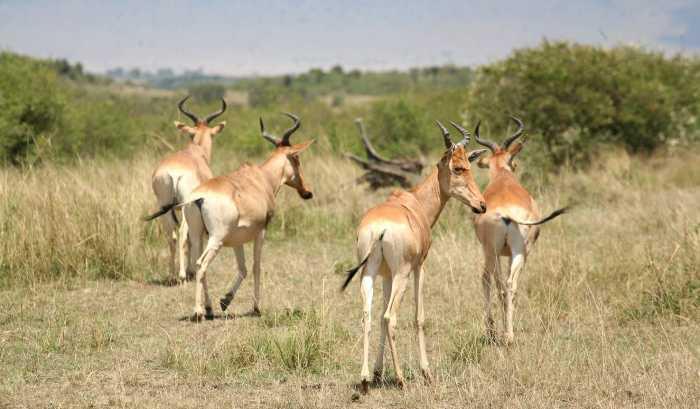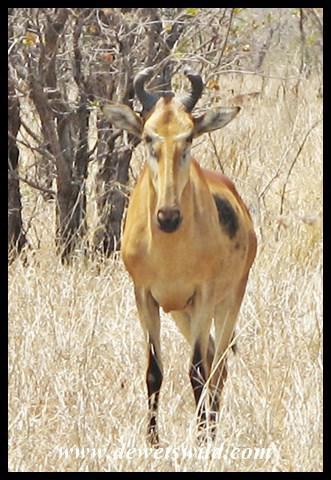The first image is the image on the left, the second image is the image on the right. Given the left and right images, does the statement "One image contains at least three times the number of hooved animals as the other image." hold true? Answer yes or no. Yes. The first image is the image on the left, the second image is the image on the right. Considering the images on both sides, is "One of the images has only one living creature." valid? Answer yes or no. Yes. 